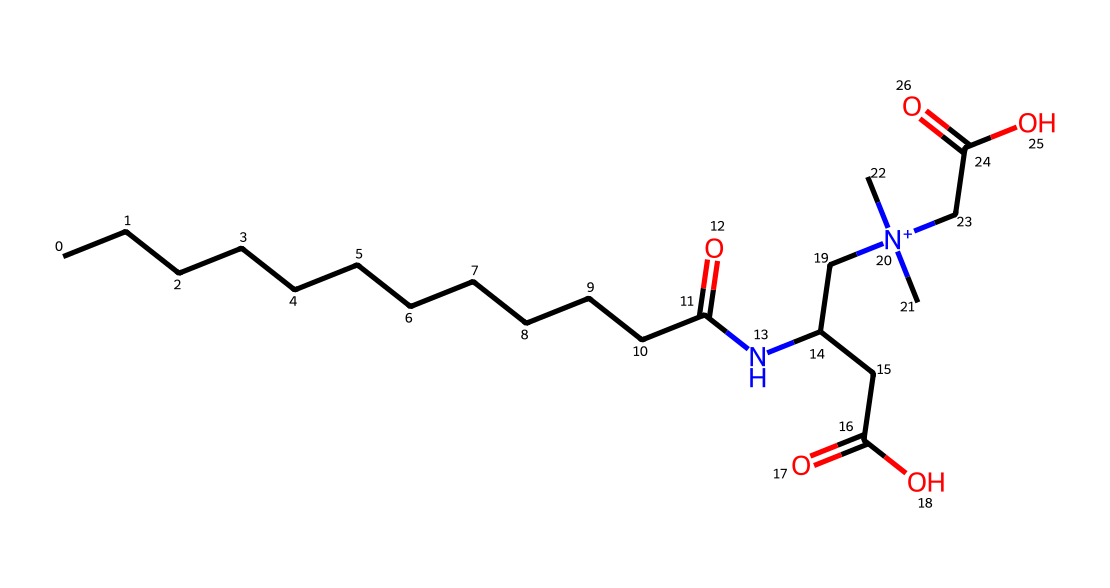What is the molecular formula of cocamidopropyl betaine? The molecular formula can be derived from counting the atoms represented in the SMILES notation. The breakdown reveals there are 19 carbon (C) atoms, 36 hydrogen (H) atoms, 2 nitrogen (N) atoms, and 4 oxygen (O) atoms.
Answer: C19H36N2O4 How many nitrogen atoms are present in this structure? By examining the structure indicated by the SMILES, there are two distinct nitrogen (N) atoms present in the molecule as seen in the part of the formula that includes "N".
Answer: 2 What is the functional group indicated by "N+" in this chemical? The "N+" indicates that there is a quaternary ammonium group, which is characteristic of cationic surfactants often found in detergents. This group typically gives the molecule its surfactant properties.
Answer: quaternary ammonium How many carbon atoms are in the long hydrocarbon chain of the surfactant? Observing the structure, the "CCCCCCCCCCCC" part signifies a long hydrocarbon chain with 12 carbon atoms.
Answer: 12 What functional group is responsible for the surfactant properties of cocamidopropyl betaine? The presence of the carboxylate group (indicated by "C(=O)O") contributes to its surfactant properties, enhancing its ability to interact with water and oils.
Answer: carboxylate group Which part of the molecule contributes to its amphoteric nature? The molecule contains both a quaternary ammonium group and a carboxylate group, meaning it can act as both an acid and a base, thus allowing it to behave in an amphoteric manner.
Answer: quaternary ammonium and carboxylate group 